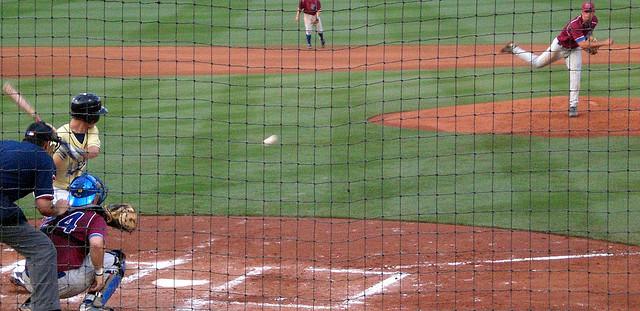Is the ball in the air?
Quick response, please. Yes. Is the shortstop playing for the hitter to pull the ball?
Quick response, please. Yes. What number is on the catcher's jersey?
Give a very brief answer. 24. 